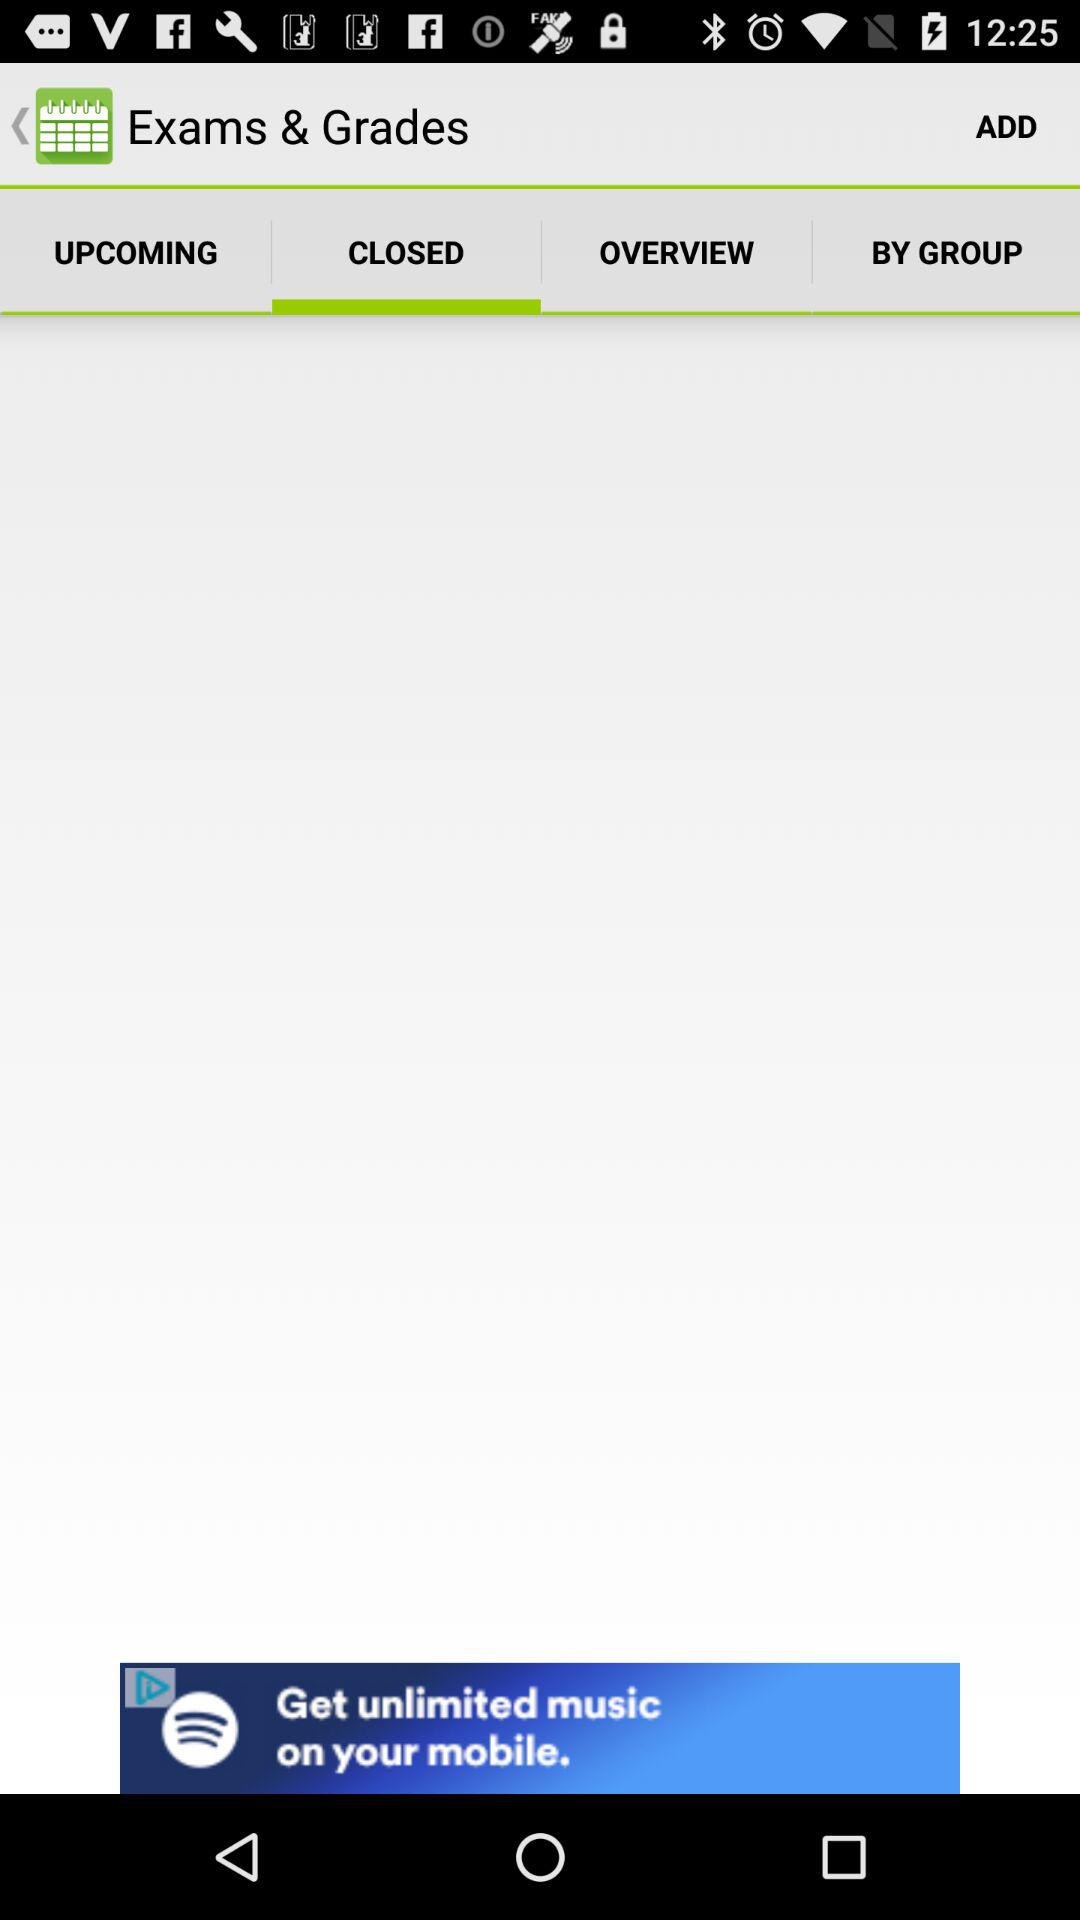What is the name of the application in the advertisement? The name of the application in the advertisement is "Spotify". 